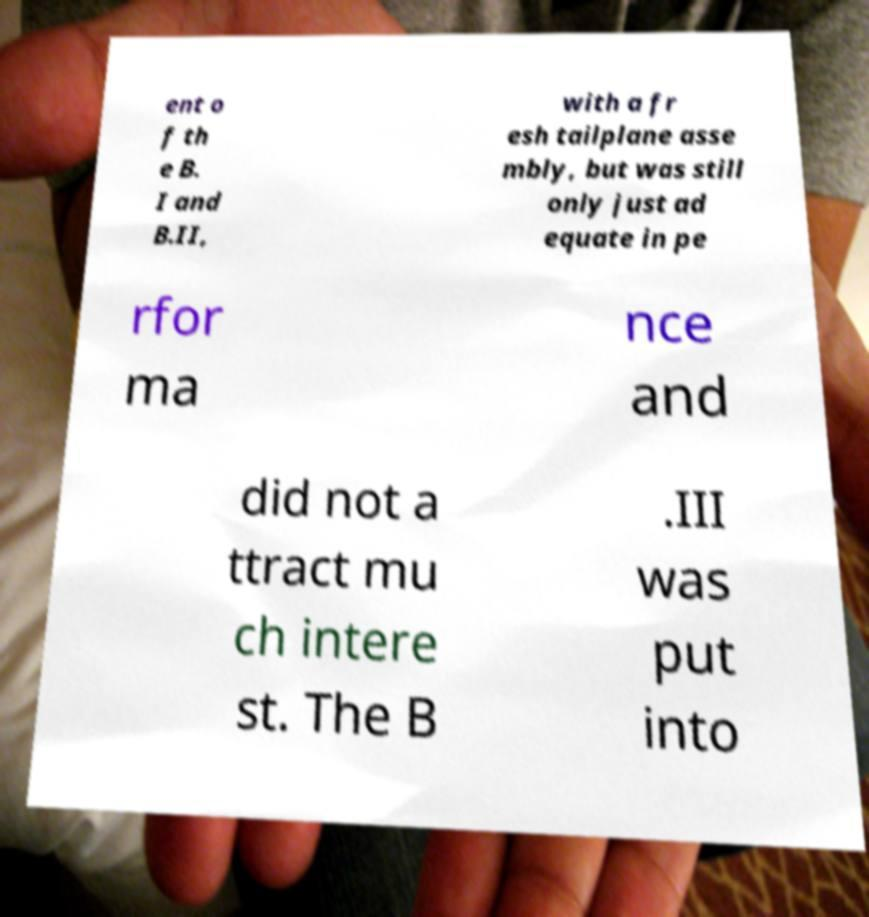What messages or text are displayed in this image? I need them in a readable, typed format. ent o f th e B. I and B.II, with a fr esh tailplane asse mbly, but was still only just ad equate in pe rfor ma nce and did not a ttract mu ch intere st. The B .III was put into 